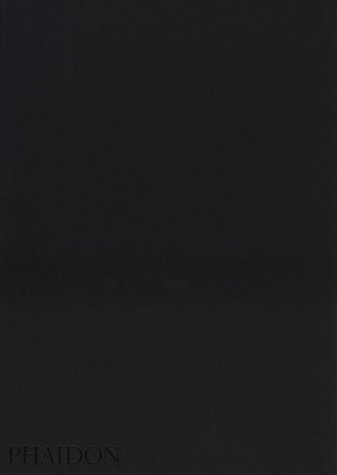What is the title of this book? 'The Mennonites' is the title of the book, which delves into the life and culture of the Mennonite community through compelling photography. 